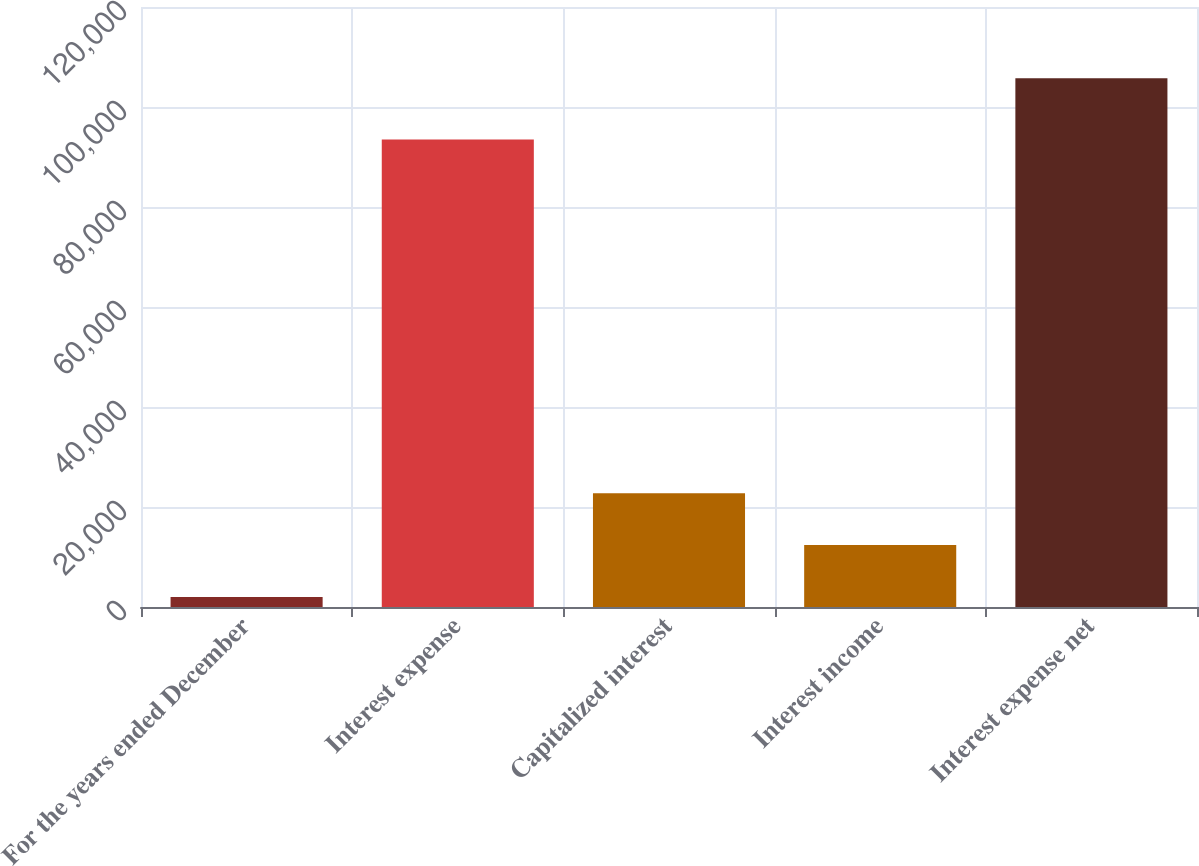<chart> <loc_0><loc_0><loc_500><loc_500><bar_chart><fcel>For the years ended December<fcel>Interest expense<fcel>Capitalized interest<fcel>Interest income<fcel>Interest expense net<nl><fcel>2015<fcel>93520<fcel>22766.6<fcel>12390.8<fcel>105773<nl></chart> 